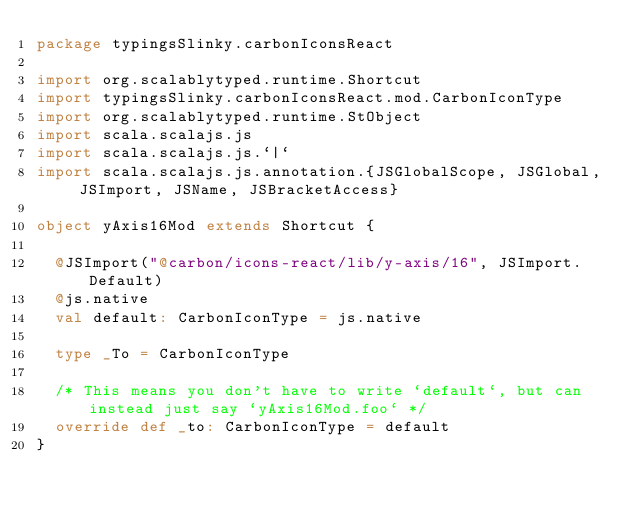<code> <loc_0><loc_0><loc_500><loc_500><_Scala_>package typingsSlinky.carbonIconsReact

import org.scalablytyped.runtime.Shortcut
import typingsSlinky.carbonIconsReact.mod.CarbonIconType
import org.scalablytyped.runtime.StObject
import scala.scalajs.js
import scala.scalajs.js.`|`
import scala.scalajs.js.annotation.{JSGlobalScope, JSGlobal, JSImport, JSName, JSBracketAccess}

object yAxis16Mod extends Shortcut {
  
  @JSImport("@carbon/icons-react/lib/y-axis/16", JSImport.Default)
  @js.native
  val default: CarbonIconType = js.native
  
  type _To = CarbonIconType
  
  /* This means you don't have to write `default`, but can instead just say `yAxis16Mod.foo` */
  override def _to: CarbonIconType = default
}
</code> 